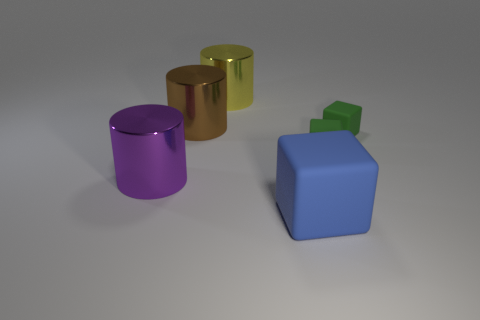Are there any other things of the same color as the big matte thing?
Offer a very short reply. No. There is a large object that is on the right side of the big yellow cylinder right of the shiny cylinder left of the brown shiny cylinder; what is its shape?
Keep it short and to the point. Cube. Is the size of the object in front of the big purple shiny thing the same as the shiny cylinder that is right of the brown cylinder?
Make the answer very short. Yes. What number of other purple objects are the same material as the purple thing?
Your response must be concise. 0. There is a large thing to the right of the yellow metal thing that is on the right side of the large purple object; how many tiny green rubber cubes are behind it?
Your answer should be very brief. 2. Do the big brown thing and the blue thing have the same shape?
Give a very brief answer. No. Are there any yellow metallic objects of the same shape as the purple metal object?
Offer a very short reply. Yes. What shape is the rubber object that is the same size as the purple metallic cylinder?
Provide a succinct answer. Cube. What is the large thing to the right of the big yellow shiny cylinder that is behind the shiny cylinder in front of the large brown metallic object made of?
Make the answer very short. Rubber. Do the brown cylinder and the yellow metallic cylinder have the same size?
Provide a short and direct response. Yes. 